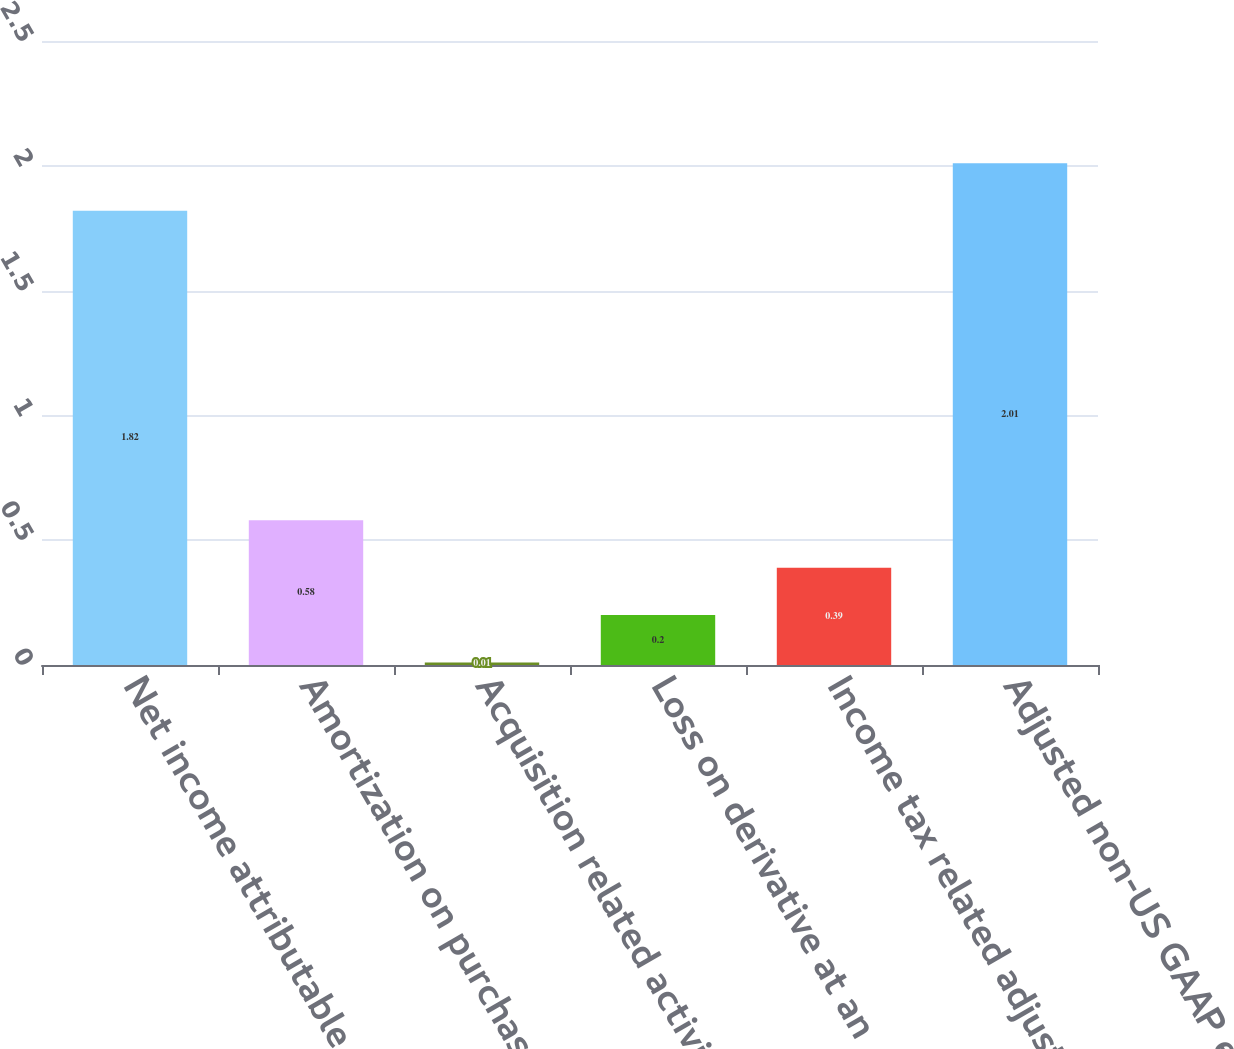Convert chart to OTSL. <chart><loc_0><loc_0><loc_500><loc_500><bar_chart><fcel>Net income attributable to<fcel>Amortization on purchased<fcel>Acquisition related activities<fcel>Loss on derivative at an<fcel>Income tax related adjustments<fcel>Adjusted non-US GAAP earnings<nl><fcel>1.82<fcel>0.58<fcel>0.01<fcel>0.2<fcel>0.39<fcel>2.01<nl></chart> 